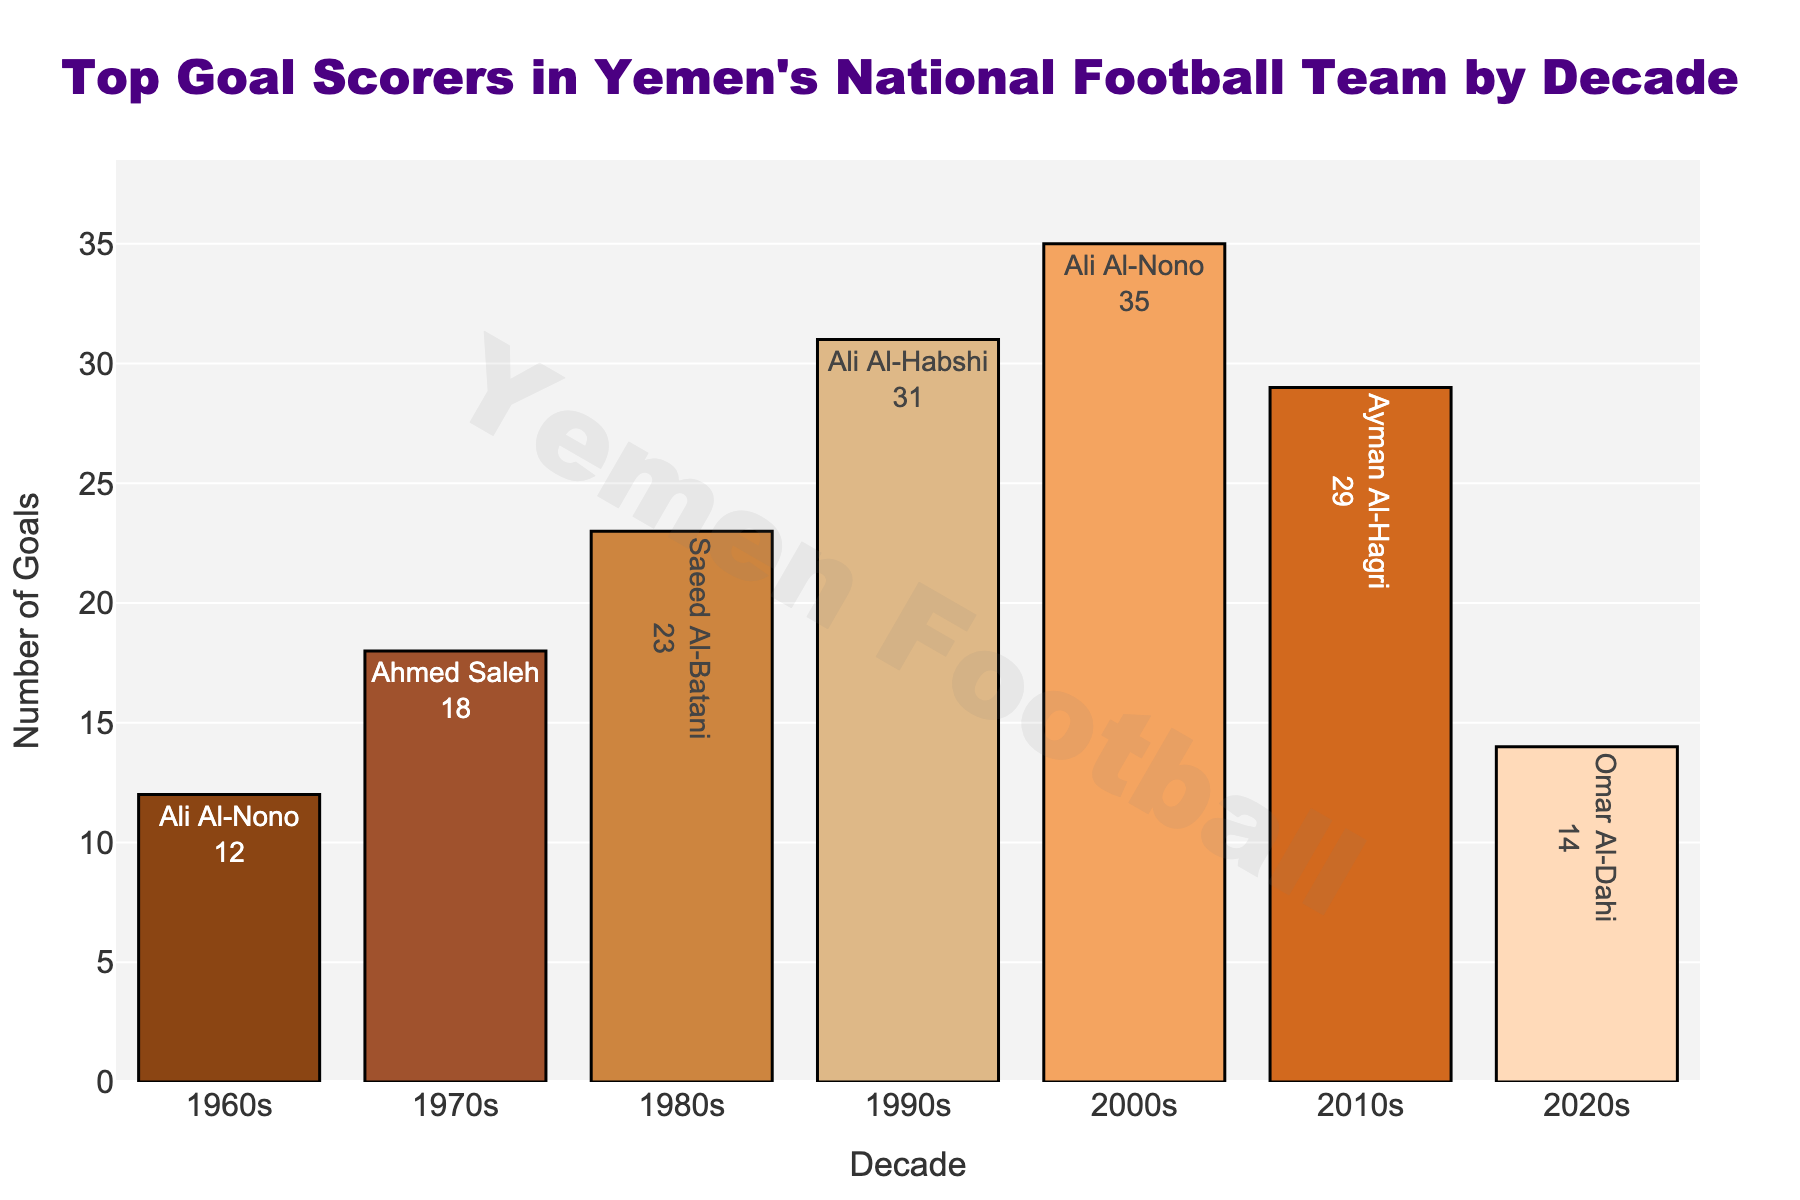Which decade's top scorer scored the highest number of goals? From the bar chart, the highest bar represents the decade whose top scorer has the most goals. The 2000s decade shows the highest bar with Ali Al-Nono scoring 35 goals.
Answer: 2000s Who was the top scorer in the 1990s and how many goals did he score? The bar for the 1990s shows Ali Al-Habshi as the top scorer with the text label indicating he scored 31 goals.
Answer: Ali Al-Habshi, 31 Which two decades had top scorers with the same first name, and what is that name? The bars for the 1960s and 2000s both show a top scorer named Ali Al-Nono.
Answer: 1960s and 2000s, Ali Al-Nono How many more goals did the top scorer of the 2000s score compared to the top scorer of the 1980s? The top scorer of the 2000s, Ali Al-Nono, scored 35 goals, while Saeed Al-Batani of the 1980s scored 23. The difference is 35 - 23 = 12 goals.
Answer: 12 What is the average number of goals scored by the top scorers across all decades? The total number of goals is 12 + 18 + 23 + 31 + 35 + 29 + 14 = 162. There are 7 decades, so the average is 162 / 7 ≈ 23.14.
Answer: 23.14 Which decade's top scorer scored the lowest number of goals and how many? The shortest bar represents the decade with the least goals. The 1960s, shown by Ali Al-Nono, scored 12 goals, which is the lowest.
Answer: 1960s, 12 How many more goals did the top scorer of the 1970s score compared to the top scorer of the 2020s? The top scorer of the 1970s, Ahmed Saleh, scored 18 goals, and Omar Al-Dahi of the 2020s scored 14 goals. The difference is 18 - 14 = 4 goals.
Answer: 4 What is the total number of goals scored by all top scorers from the 1990s to the 2020s? Summing the goals from the 1990s onward (decades 1990s, 2000s, 2010s, 2020s) gives 31 + 35 + 29 + 14 = 109 goals.
Answer: 109 In which decade did the top scorer score more goals: the 1980s or the 2010s? Comparing the bars, the top scorer of the 2010s (Ayman Al-Hagri with 29 goals) scored more than the top scorer of the 1980s (Saeed Al-Batani with 23 goals).
Answer: 2010s 